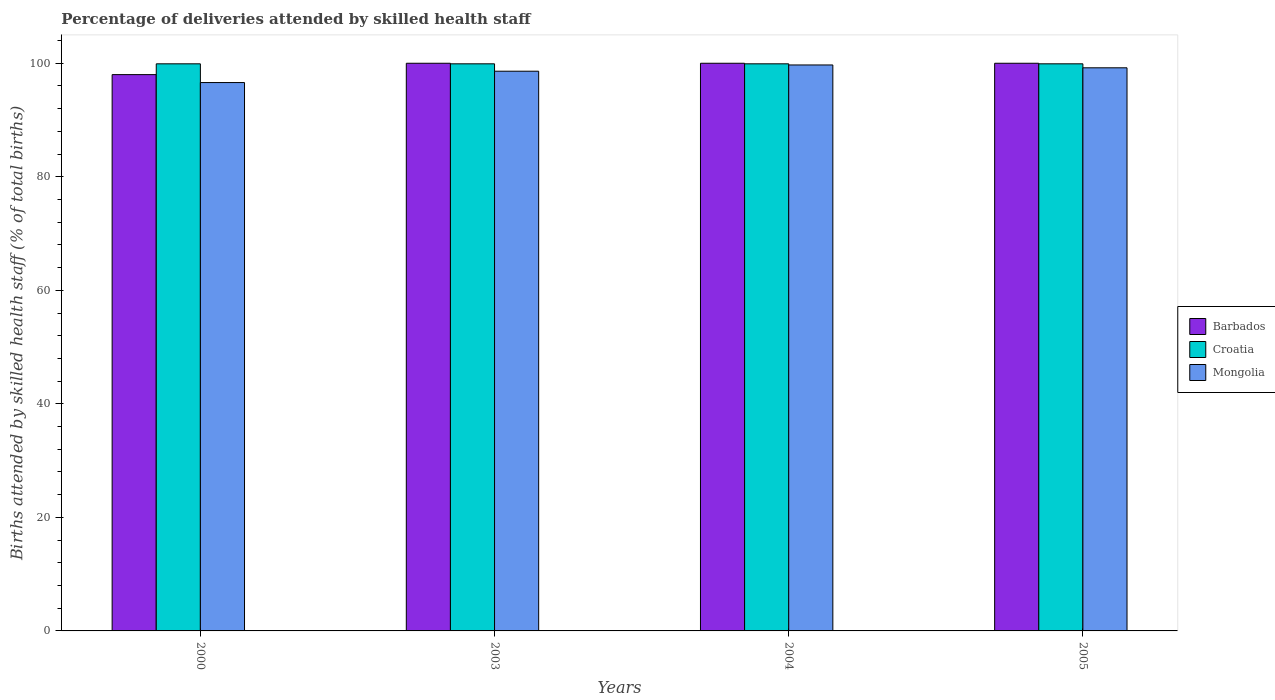How many different coloured bars are there?
Offer a very short reply. 3. What is the label of the 2nd group of bars from the left?
Provide a succinct answer. 2003. What is the percentage of births attended by skilled health staff in Croatia in 2004?
Provide a short and direct response. 99.9. Across all years, what is the maximum percentage of births attended by skilled health staff in Mongolia?
Give a very brief answer. 99.7. Across all years, what is the minimum percentage of births attended by skilled health staff in Croatia?
Give a very brief answer. 99.9. In which year was the percentage of births attended by skilled health staff in Croatia maximum?
Your answer should be compact. 2000. What is the total percentage of births attended by skilled health staff in Barbados in the graph?
Make the answer very short. 398. What is the difference between the percentage of births attended by skilled health staff in Mongolia in 2000 and that in 2005?
Provide a short and direct response. -2.6. What is the difference between the percentage of births attended by skilled health staff in Croatia in 2000 and the percentage of births attended by skilled health staff in Barbados in 2004?
Offer a terse response. -0.1. What is the average percentage of births attended by skilled health staff in Croatia per year?
Provide a short and direct response. 99.9. In the year 2005, what is the difference between the percentage of births attended by skilled health staff in Croatia and percentage of births attended by skilled health staff in Barbados?
Provide a succinct answer. -0.1. In how many years, is the percentage of births attended by skilled health staff in Mongolia greater than 84 %?
Keep it short and to the point. 4. What is the ratio of the percentage of births attended by skilled health staff in Mongolia in 2000 to that in 2005?
Provide a succinct answer. 0.97. Is the difference between the percentage of births attended by skilled health staff in Croatia in 2003 and 2004 greater than the difference between the percentage of births attended by skilled health staff in Barbados in 2003 and 2004?
Your answer should be compact. No. In how many years, is the percentage of births attended by skilled health staff in Croatia greater than the average percentage of births attended by skilled health staff in Croatia taken over all years?
Provide a short and direct response. 0. What does the 3rd bar from the left in 2005 represents?
Your answer should be very brief. Mongolia. What does the 3rd bar from the right in 2000 represents?
Offer a very short reply. Barbados. How many years are there in the graph?
Ensure brevity in your answer.  4. Are the values on the major ticks of Y-axis written in scientific E-notation?
Provide a short and direct response. No. Does the graph contain grids?
Your response must be concise. No. Where does the legend appear in the graph?
Provide a succinct answer. Center right. How many legend labels are there?
Give a very brief answer. 3. How are the legend labels stacked?
Offer a terse response. Vertical. What is the title of the graph?
Your answer should be very brief. Percentage of deliveries attended by skilled health staff. Does "Finland" appear as one of the legend labels in the graph?
Make the answer very short. No. What is the label or title of the Y-axis?
Your answer should be very brief. Births attended by skilled health staff (% of total births). What is the Births attended by skilled health staff (% of total births) in Barbados in 2000?
Offer a terse response. 98. What is the Births attended by skilled health staff (% of total births) of Croatia in 2000?
Ensure brevity in your answer.  99.9. What is the Births attended by skilled health staff (% of total births) in Mongolia in 2000?
Your answer should be very brief. 96.6. What is the Births attended by skilled health staff (% of total births) of Croatia in 2003?
Offer a very short reply. 99.9. What is the Births attended by skilled health staff (% of total births) in Mongolia in 2003?
Make the answer very short. 98.6. What is the Births attended by skilled health staff (% of total births) of Croatia in 2004?
Provide a succinct answer. 99.9. What is the Births attended by skilled health staff (% of total births) of Mongolia in 2004?
Make the answer very short. 99.7. What is the Births attended by skilled health staff (% of total births) of Croatia in 2005?
Keep it short and to the point. 99.9. What is the Births attended by skilled health staff (% of total births) in Mongolia in 2005?
Your response must be concise. 99.2. Across all years, what is the maximum Births attended by skilled health staff (% of total births) in Barbados?
Make the answer very short. 100. Across all years, what is the maximum Births attended by skilled health staff (% of total births) of Croatia?
Your response must be concise. 99.9. Across all years, what is the maximum Births attended by skilled health staff (% of total births) in Mongolia?
Provide a short and direct response. 99.7. Across all years, what is the minimum Births attended by skilled health staff (% of total births) in Croatia?
Give a very brief answer. 99.9. Across all years, what is the minimum Births attended by skilled health staff (% of total births) of Mongolia?
Your answer should be very brief. 96.6. What is the total Births attended by skilled health staff (% of total births) in Barbados in the graph?
Keep it short and to the point. 398. What is the total Births attended by skilled health staff (% of total births) in Croatia in the graph?
Keep it short and to the point. 399.6. What is the total Births attended by skilled health staff (% of total births) of Mongolia in the graph?
Your answer should be very brief. 394.1. What is the difference between the Births attended by skilled health staff (% of total births) of Barbados in 2000 and that in 2003?
Your response must be concise. -2. What is the difference between the Births attended by skilled health staff (% of total births) in Mongolia in 2000 and that in 2003?
Your answer should be very brief. -2. What is the difference between the Births attended by skilled health staff (% of total births) in Mongolia in 2000 and that in 2005?
Your answer should be very brief. -2.6. What is the difference between the Births attended by skilled health staff (% of total births) of Mongolia in 2003 and that in 2004?
Your answer should be compact. -1.1. What is the difference between the Births attended by skilled health staff (% of total births) of Croatia in 2000 and the Births attended by skilled health staff (% of total births) of Mongolia in 2003?
Offer a terse response. 1.3. What is the difference between the Births attended by skilled health staff (% of total births) of Barbados in 2000 and the Births attended by skilled health staff (% of total births) of Mongolia in 2004?
Keep it short and to the point. -1.7. What is the difference between the Births attended by skilled health staff (% of total births) of Barbados in 2003 and the Births attended by skilled health staff (% of total births) of Croatia in 2004?
Your answer should be very brief. 0.1. What is the difference between the Births attended by skilled health staff (% of total births) of Barbados in 2003 and the Births attended by skilled health staff (% of total births) of Mongolia in 2004?
Make the answer very short. 0.3. What is the difference between the Births attended by skilled health staff (% of total births) in Croatia in 2003 and the Births attended by skilled health staff (% of total births) in Mongolia in 2004?
Your response must be concise. 0.2. What is the difference between the Births attended by skilled health staff (% of total births) in Barbados in 2003 and the Births attended by skilled health staff (% of total births) in Mongolia in 2005?
Provide a short and direct response. 0.8. What is the difference between the Births attended by skilled health staff (% of total births) of Barbados in 2004 and the Births attended by skilled health staff (% of total births) of Mongolia in 2005?
Your response must be concise. 0.8. What is the average Births attended by skilled health staff (% of total births) in Barbados per year?
Offer a very short reply. 99.5. What is the average Births attended by skilled health staff (% of total births) in Croatia per year?
Ensure brevity in your answer.  99.9. What is the average Births attended by skilled health staff (% of total births) in Mongolia per year?
Your answer should be compact. 98.53. In the year 2000, what is the difference between the Births attended by skilled health staff (% of total births) of Barbados and Births attended by skilled health staff (% of total births) of Croatia?
Make the answer very short. -1.9. In the year 2000, what is the difference between the Births attended by skilled health staff (% of total births) in Croatia and Births attended by skilled health staff (% of total births) in Mongolia?
Your answer should be very brief. 3.3. In the year 2003, what is the difference between the Births attended by skilled health staff (% of total births) in Barbados and Births attended by skilled health staff (% of total births) in Croatia?
Provide a succinct answer. 0.1. In the year 2003, what is the difference between the Births attended by skilled health staff (% of total births) of Croatia and Births attended by skilled health staff (% of total births) of Mongolia?
Your answer should be compact. 1.3. In the year 2004, what is the difference between the Births attended by skilled health staff (% of total births) of Barbados and Births attended by skilled health staff (% of total births) of Mongolia?
Your response must be concise. 0.3. In the year 2004, what is the difference between the Births attended by skilled health staff (% of total births) in Croatia and Births attended by skilled health staff (% of total births) in Mongolia?
Provide a succinct answer. 0.2. What is the ratio of the Births attended by skilled health staff (% of total births) in Barbados in 2000 to that in 2003?
Provide a succinct answer. 0.98. What is the ratio of the Births attended by skilled health staff (% of total births) in Mongolia in 2000 to that in 2003?
Your answer should be very brief. 0.98. What is the ratio of the Births attended by skilled health staff (% of total births) of Mongolia in 2000 to that in 2004?
Provide a succinct answer. 0.97. What is the ratio of the Births attended by skilled health staff (% of total births) of Barbados in 2000 to that in 2005?
Make the answer very short. 0.98. What is the ratio of the Births attended by skilled health staff (% of total births) in Croatia in 2000 to that in 2005?
Your answer should be compact. 1. What is the ratio of the Births attended by skilled health staff (% of total births) of Mongolia in 2000 to that in 2005?
Your answer should be very brief. 0.97. What is the ratio of the Births attended by skilled health staff (% of total births) of Mongolia in 2003 to that in 2004?
Make the answer very short. 0.99. What is the ratio of the Births attended by skilled health staff (% of total births) of Mongolia in 2003 to that in 2005?
Your answer should be very brief. 0.99. What is the ratio of the Births attended by skilled health staff (% of total births) of Mongolia in 2004 to that in 2005?
Provide a short and direct response. 1. 